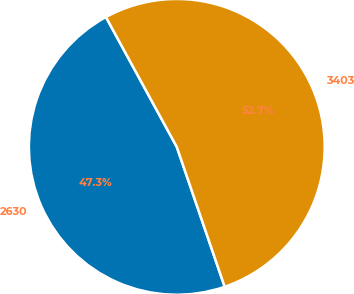<chart> <loc_0><loc_0><loc_500><loc_500><pie_chart><fcel>2630<fcel>3403<nl><fcel>47.3%<fcel>52.7%<nl></chart> 